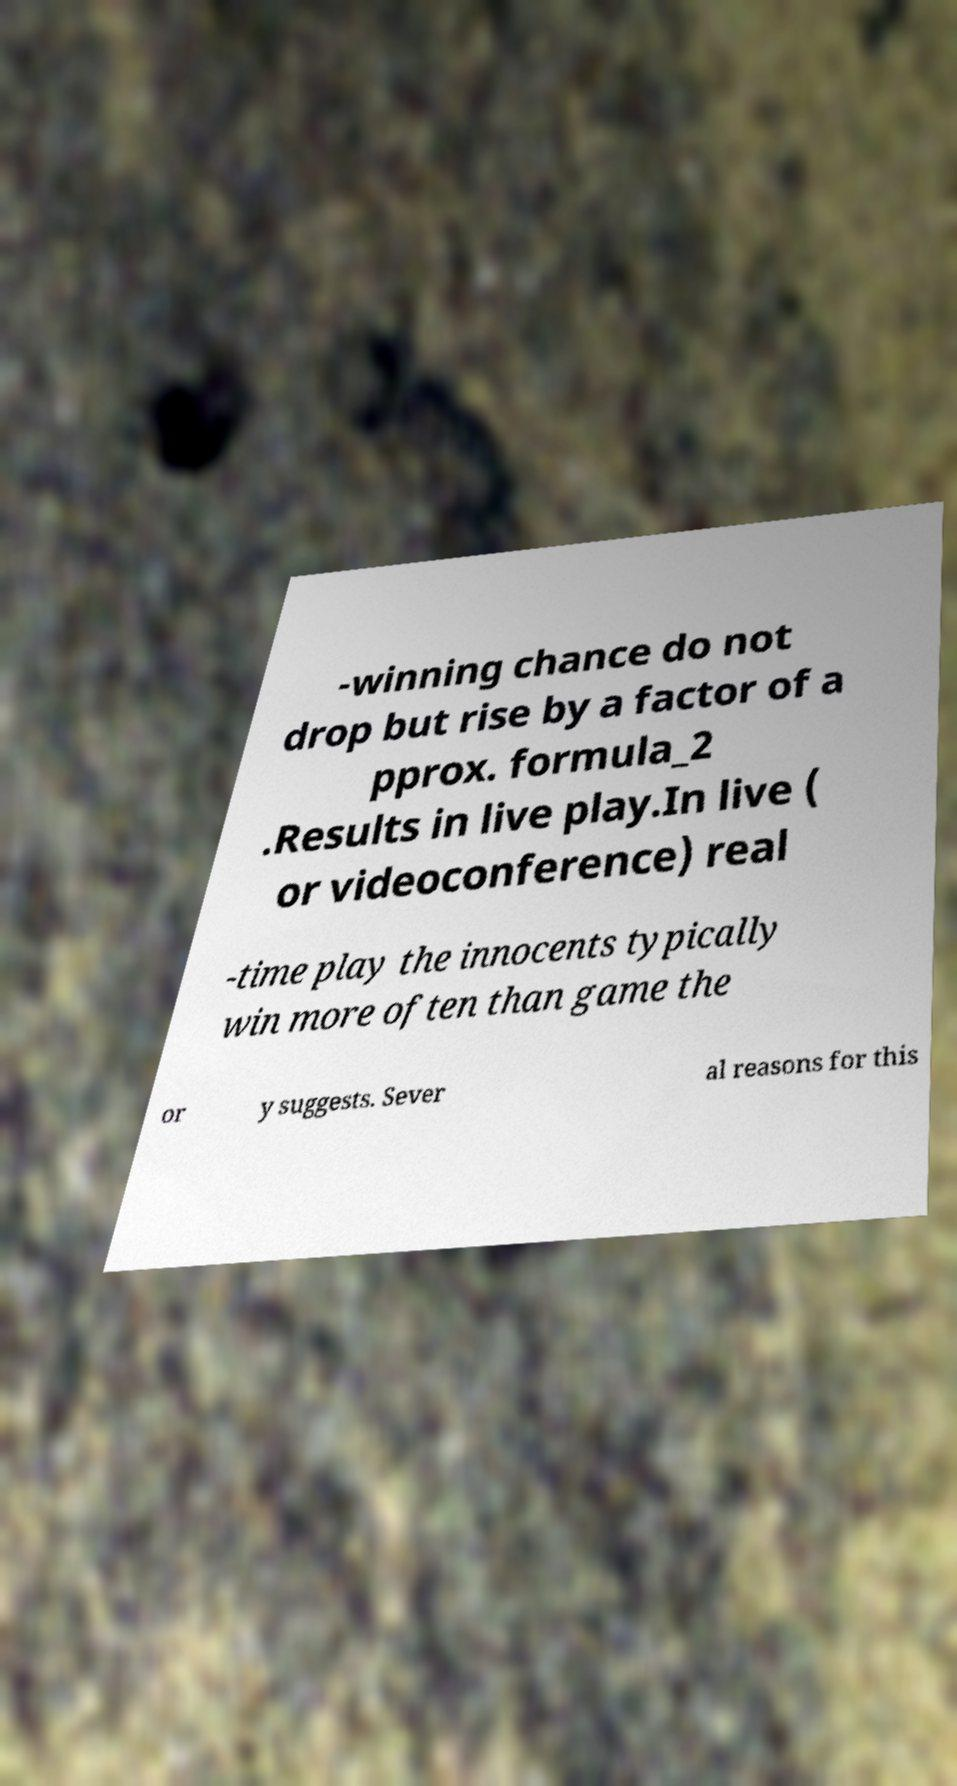Please read and relay the text visible in this image. What does it say? -winning chance do not drop but rise by a factor of a pprox. formula_2 .Results in live play.In live ( or videoconference) real -time play the innocents typically win more often than game the or y suggests. Sever al reasons for this 